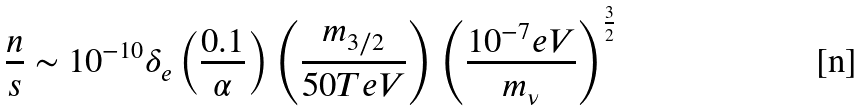<formula> <loc_0><loc_0><loc_500><loc_500>\frac { n } { s } \sim 1 0 ^ { - 1 0 } \delta _ { e } \left ( \frac { 0 . 1 } { \alpha } \right ) \left ( \frac { m _ { 3 / 2 } } { 5 0 T e V } \right ) \left ( \frac { 1 0 ^ { - 7 } e V } { m _ { \nu } } \right ) ^ { \frac { 3 } { 2 } }</formula> 